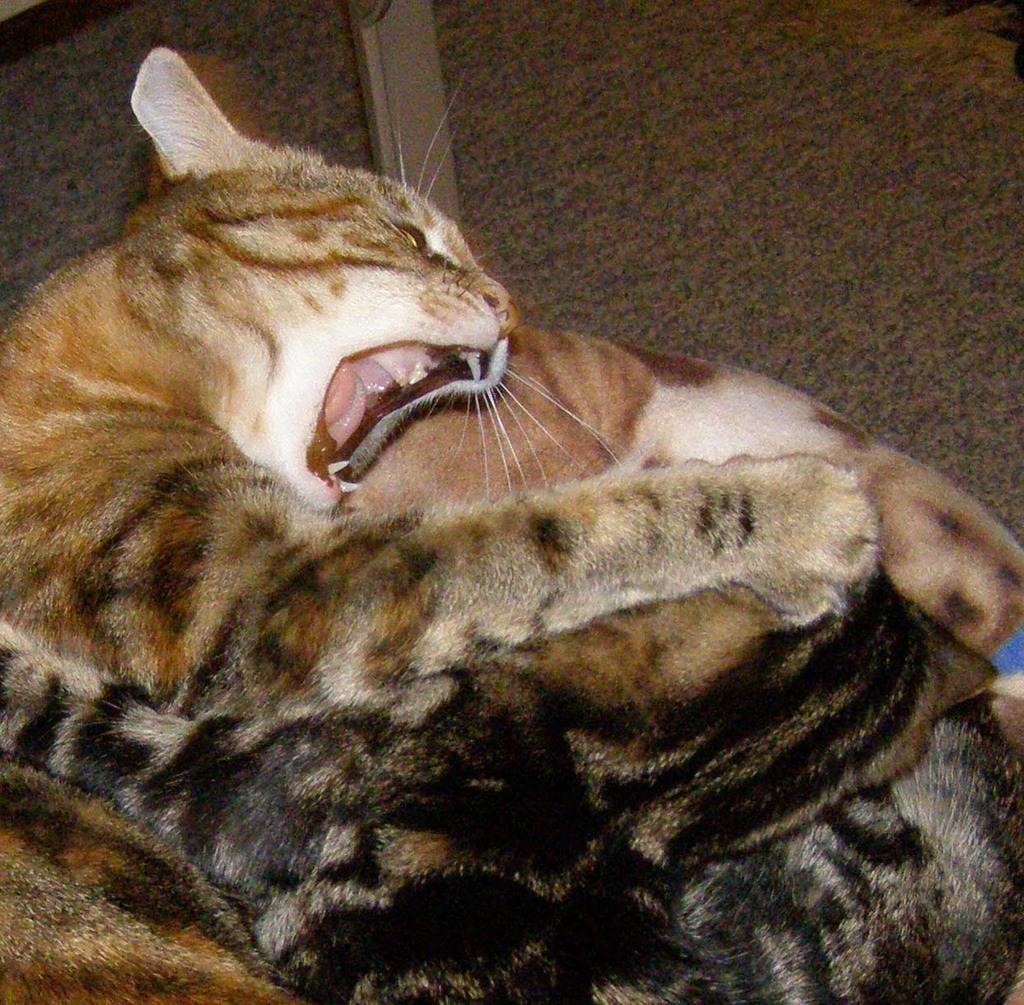How would you summarize this image in a sentence or two? In this picture, it seems like a cat on a blanket in the foreground. 